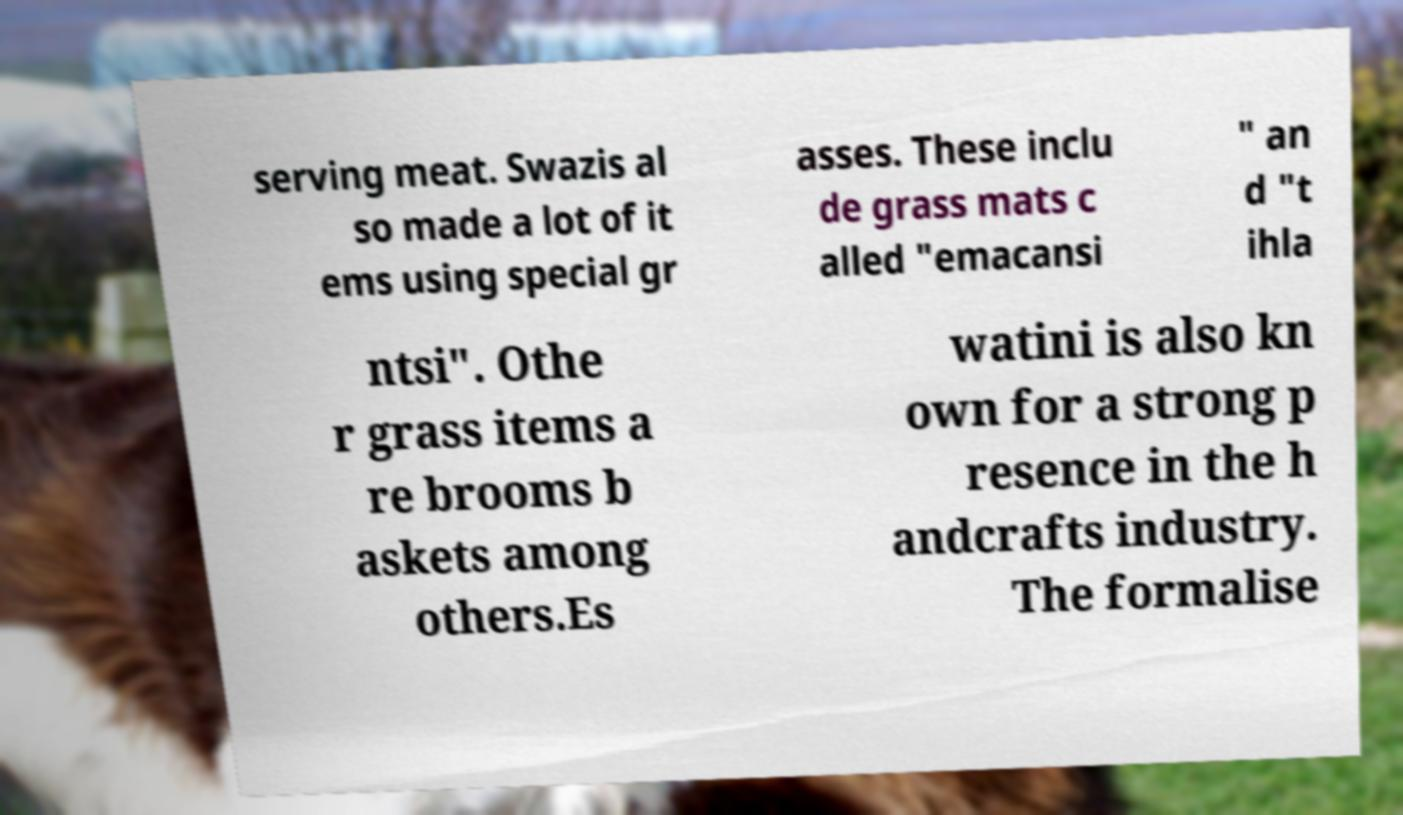Could you extract and type out the text from this image? serving meat. Swazis al so made a lot of it ems using special gr asses. These inclu de grass mats c alled "emacansi " an d "t ihla ntsi". Othe r grass items a re brooms b askets among others.Es watini is also kn own for a strong p resence in the h andcrafts industry. The formalise 